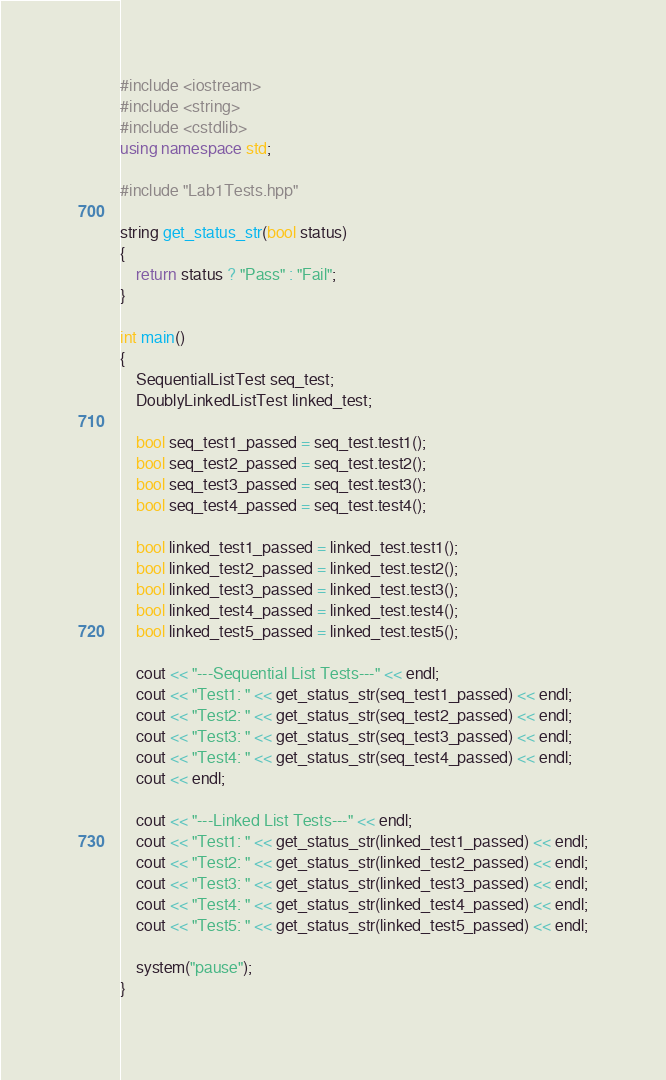Convert code to text. <code><loc_0><loc_0><loc_500><loc_500><_C++_>#include <iostream>
#include <string>
#include <cstdlib>
using namespace std;

#include "Lab1Tests.hpp"

string get_status_str(bool status)
{
    return status ? "Pass" : "Fail";
}

int main()
{
    SequentialListTest seq_test;
    DoublyLinkedListTest linked_test;
    
    bool seq_test1_passed = seq_test.test1();
    bool seq_test2_passed = seq_test.test2();
    bool seq_test3_passed = seq_test.test3();
    bool seq_test4_passed = seq_test.test4();
    
    bool linked_test1_passed = linked_test.test1();
    bool linked_test2_passed = linked_test.test2();
    bool linked_test3_passed = linked_test.test3();
    bool linked_test4_passed = linked_test.test4();
    bool linked_test5_passed = linked_test.test5();
    
    cout << "---Sequential List Tests---" << endl;
    cout << "Test1: " << get_status_str(seq_test1_passed) << endl;
    cout << "Test2: " << get_status_str(seq_test2_passed) << endl;
    cout << "Test3: " << get_status_str(seq_test3_passed) << endl;
    cout << "Test4: " << get_status_str(seq_test4_passed) << endl;
    cout << endl;
    
    cout << "---Linked List Tests---" << endl;
    cout << "Test1: " << get_status_str(linked_test1_passed) << endl;
    cout << "Test2: " << get_status_str(linked_test2_passed) << endl;
    cout << "Test3: " << get_status_str(linked_test3_passed) << endl;
    cout << "Test4: " << get_status_str(linked_test4_passed) << endl;
    cout << "Test5: " << get_status_str(linked_test5_passed) << endl;
    
    system("pause");
}

</code> 